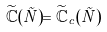Convert formula to latex. <formula><loc_0><loc_0><loc_500><loc_500>\widetilde { \mathbb { C } } ( \vec { N } ) = \widetilde { \mathbb { C } } _ { c } ( \vec { N } )</formula> 